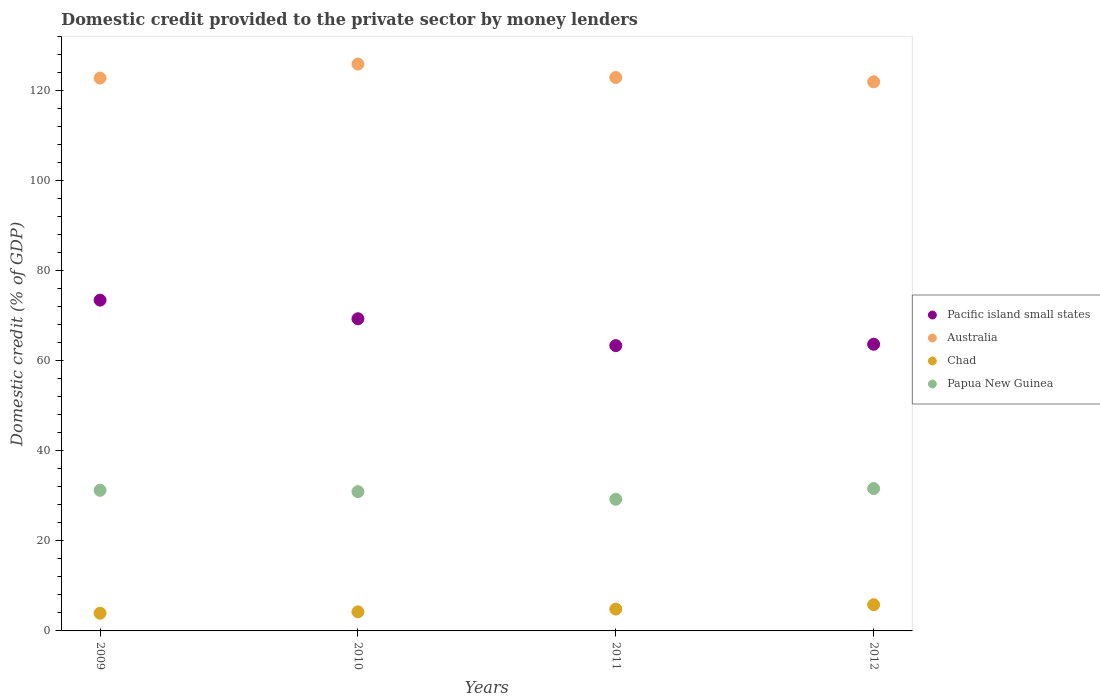How many different coloured dotlines are there?
Offer a terse response. 4. What is the domestic credit provided to the private sector by money lenders in Papua New Guinea in 2012?
Your response must be concise. 31.62. Across all years, what is the maximum domestic credit provided to the private sector by money lenders in Australia?
Keep it short and to the point. 125.92. Across all years, what is the minimum domestic credit provided to the private sector by money lenders in Chad?
Your response must be concise. 3.93. In which year was the domestic credit provided to the private sector by money lenders in Papua New Guinea maximum?
Offer a very short reply. 2012. What is the total domestic credit provided to the private sector by money lenders in Pacific island small states in the graph?
Give a very brief answer. 269.87. What is the difference between the domestic credit provided to the private sector by money lenders in Australia in 2009 and that in 2012?
Your answer should be very brief. 0.83. What is the difference between the domestic credit provided to the private sector by money lenders in Pacific island small states in 2011 and the domestic credit provided to the private sector by money lenders in Australia in 2010?
Give a very brief answer. -62.55. What is the average domestic credit provided to the private sector by money lenders in Australia per year?
Provide a succinct answer. 123.4. In the year 2010, what is the difference between the domestic credit provided to the private sector by money lenders in Chad and domestic credit provided to the private sector by money lenders in Pacific island small states?
Offer a very short reply. -65.1. In how many years, is the domestic credit provided to the private sector by money lenders in Papua New Guinea greater than 96 %?
Your answer should be very brief. 0. What is the ratio of the domestic credit provided to the private sector by money lenders in Pacific island small states in 2011 to that in 2012?
Provide a succinct answer. 1. What is the difference between the highest and the second highest domestic credit provided to the private sector by money lenders in Pacific island small states?
Make the answer very short. 4.14. What is the difference between the highest and the lowest domestic credit provided to the private sector by money lenders in Pacific island small states?
Your answer should be very brief. 10.1. Is the sum of the domestic credit provided to the private sector by money lenders in Australia in 2011 and 2012 greater than the maximum domestic credit provided to the private sector by money lenders in Chad across all years?
Your response must be concise. Yes. Is it the case that in every year, the sum of the domestic credit provided to the private sector by money lenders in Papua New Guinea and domestic credit provided to the private sector by money lenders in Australia  is greater than the sum of domestic credit provided to the private sector by money lenders in Pacific island small states and domestic credit provided to the private sector by money lenders in Chad?
Keep it short and to the point. Yes. Is it the case that in every year, the sum of the domestic credit provided to the private sector by money lenders in Pacific island small states and domestic credit provided to the private sector by money lenders in Australia  is greater than the domestic credit provided to the private sector by money lenders in Chad?
Offer a terse response. Yes. Is the domestic credit provided to the private sector by money lenders in Australia strictly greater than the domestic credit provided to the private sector by money lenders in Papua New Guinea over the years?
Offer a very short reply. Yes. Is the domestic credit provided to the private sector by money lenders in Australia strictly less than the domestic credit provided to the private sector by money lenders in Pacific island small states over the years?
Ensure brevity in your answer.  No. How many years are there in the graph?
Your answer should be very brief. 4. Does the graph contain any zero values?
Give a very brief answer. No. Does the graph contain grids?
Your response must be concise. No. Where does the legend appear in the graph?
Keep it short and to the point. Center right. How are the legend labels stacked?
Provide a succinct answer. Vertical. What is the title of the graph?
Provide a short and direct response. Domestic credit provided to the private sector by money lenders. Does "Burkina Faso" appear as one of the legend labels in the graph?
Give a very brief answer. No. What is the label or title of the X-axis?
Provide a short and direct response. Years. What is the label or title of the Y-axis?
Offer a very short reply. Domestic credit (% of GDP). What is the Domestic credit (% of GDP) of Pacific island small states in 2009?
Your answer should be very brief. 73.48. What is the Domestic credit (% of GDP) in Australia in 2009?
Offer a terse response. 122.8. What is the Domestic credit (% of GDP) of Chad in 2009?
Make the answer very short. 3.93. What is the Domestic credit (% of GDP) of Papua New Guinea in 2009?
Give a very brief answer. 31.23. What is the Domestic credit (% of GDP) of Pacific island small states in 2010?
Provide a succinct answer. 69.34. What is the Domestic credit (% of GDP) in Australia in 2010?
Provide a succinct answer. 125.92. What is the Domestic credit (% of GDP) of Chad in 2010?
Give a very brief answer. 4.24. What is the Domestic credit (% of GDP) in Papua New Guinea in 2010?
Your answer should be very brief. 30.94. What is the Domestic credit (% of GDP) of Pacific island small states in 2011?
Offer a terse response. 63.38. What is the Domestic credit (% of GDP) of Australia in 2011?
Your response must be concise. 122.93. What is the Domestic credit (% of GDP) of Chad in 2011?
Your response must be concise. 4.85. What is the Domestic credit (% of GDP) in Papua New Guinea in 2011?
Provide a succinct answer. 29.24. What is the Domestic credit (% of GDP) in Pacific island small states in 2012?
Provide a succinct answer. 63.67. What is the Domestic credit (% of GDP) in Australia in 2012?
Offer a very short reply. 121.97. What is the Domestic credit (% of GDP) of Chad in 2012?
Offer a very short reply. 5.82. What is the Domestic credit (% of GDP) in Papua New Guinea in 2012?
Your response must be concise. 31.62. Across all years, what is the maximum Domestic credit (% of GDP) in Pacific island small states?
Make the answer very short. 73.48. Across all years, what is the maximum Domestic credit (% of GDP) of Australia?
Keep it short and to the point. 125.92. Across all years, what is the maximum Domestic credit (% of GDP) in Chad?
Your answer should be very brief. 5.82. Across all years, what is the maximum Domestic credit (% of GDP) in Papua New Guinea?
Offer a terse response. 31.62. Across all years, what is the minimum Domestic credit (% of GDP) in Pacific island small states?
Offer a very short reply. 63.38. Across all years, what is the minimum Domestic credit (% of GDP) in Australia?
Your answer should be very brief. 121.97. Across all years, what is the minimum Domestic credit (% of GDP) in Chad?
Offer a very short reply. 3.93. Across all years, what is the minimum Domestic credit (% of GDP) of Papua New Guinea?
Offer a very short reply. 29.24. What is the total Domestic credit (% of GDP) of Pacific island small states in the graph?
Your answer should be very brief. 269.87. What is the total Domestic credit (% of GDP) in Australia in the graph?
Your answer should be compact. 493.62. What is the total Domestic credit (% of GDP) of Chad in the graph?
Make the answer very short. 18.83. What is the total Domestic credit (% of GDP) in Papua New Guinea in the graph?
Offer a very short reply. 123.04. What is the difference between the Domestic credit (% of GDP) of Pacific island small states in 2009 and that in 2010?
Provide a short and direct response. 4.14. What is the difference between the Domestic credit (% of GDP) of Australia in 2009 and that in 2010?
Offer a terse response. -3.13. What is the difference between the Domestic credit (% of GDP) of Chad in 2009 and that in 2010?
Your response must be concise. -0.31. What is the difference between the Domestic credit (% of GDP) in Papua New Guinea in 2009 and that in 2010?
Offer a terse response. 0.3. What is the difference between the Domestic credit (% of GDP) of Pacific island small states in 2009 and that in 2011?
Offer a terse response. 10.1. What is the difference between the Domestic credit (% of GDP) in Australia in 2009 and that in 2011?
Provide a succinct answer. -0.13. What is the difference between the Domestic credit (% of GDP) in Chad in 2009 and that in 2011?
Give a very brief answer. -0.92. What is the difference between the Domestic credit (% of GDP) of Papua New Guinea in 2009 and that in 2011?
Provide a short and direct response. 1.99. What is the difference between the Domestic credit (% of GDP) in Pacific island small states in 2009 and that in 2012?
Ensure brevity in your answer.  9.8. What is the difference between the Domestic credit (% of GDP) of Australia in 2009 and that in 2012?
Your response must be concise. 0.83. What is the difference between the Domestic credit (% of GDP) of Chad in 2009 and that in 2012?
Offer a very short reply. -1.89. What is the difference between the Domestic credit (% of GDP) of Papua New Guinea in 2009 and that in 2012?
Your answer should be very brief. -0.39. What is the difference between the Domestic credit (% of GDP) of Pacific island small states in 2010 and that in 2011?
Keep it short and to the point. 5.97. What is the difference between the Domestic credit (% of GDP) in Australia in 2010 and that in 2011?
Offer a very short reply. 3. What is the difference between the Domestic credit (% of GDP) in Chad in 2010 and that in 2011?
Provide a succinct answer. -0.61. What is the difference between the Domestic credit (% of GDP) of Papua New Guinea in 2010 and that in 2011?
Provide a short and direct response. 1.69. What is the difference between the Domestic credit (% of GDP) in Pacific island small states in 2010 and that in 2012?
Offer a terse response. 5.67. What is the difference between the Domestic credit (% of GDP) of Australia in 2010 and that in 2012?
Keep it short and to the point. 3.95. What is the difference between the Domestic credit (% of GDP) in Chad in 2010 and that in 2012?
Provide a short and direct response. -1.58. What is the difference between the Domestic credit (% of GDP) of Papua New Guinea in 2010 and that in 2012?
Your answer should be very brief. -0.69. What is the difference between the Domestic credit (% of GDP) in Pacific island small states in 2011 and that in 2012?
Keep it short and to the point. -0.3. What is the difference between the Domestic credit (% of GDP) in Australia in 2011 and that in 2012?
Keep it short and to the point. 0.96. What is the difference between the Domestic credit (% of GDP) of Chad in 2011 and that in 2012?
Provide a short and direct response. -0.97. What is the difference between the Domestic credit (% of GDP) of Papua New Guinea in 2011 and that in 2012?
Keep it short and to the point. -2.38. What is the difference between the Domestic credit (% of GDP) of Pacific island small states in 2009 and the Domestic credit (% of GDP) of Australia in 2010?
Make the answer very short. -52.45. What is the difference between the Domestic credit (% of GDP) of Pacific island small states in 2009 and the Domestic credit (% of GDP) of Chad in 2010?
Ensure brevity in your answer.  69.24. What is the difference between the Domestic credit (% of GDP) of Pacific island small states in 2009 and the Domestic credit (% of GDP) of Papua New Guinea in 2010?
Your answer should be very brief. 42.54. What is the difference between the Domestic credit (% of GDP) of Australia in 2009 and the Domestic credit (% of GDP) of Chad in 2010?
Make the answer very short. 118.56. What is the difference between the Domestic credit (% of GDP) in Australia in 2009 and the Domestic credit (% of GDP) in Papua New Guinea in 2010?
Provide a short and direct response. 91.86. What is the difference between the Domestic credit (% of GDP) of Chad in 2009 and the Domestic credit (% of GDP) of Papua New Guinea in 2010?
Offer a very short reply. -27. What is the difference between the Domestic credit (% of GDP) in Pacific island small states in 2009 and the Domestic credit (% of GDP) in Australia in 2011?
Keep it short and to the point. -49.45. What is the difference between the Domestic credit (% of GDP) in Pacific island small states in 2009 and the Domestic credit (% of GDP) in Chad in 2011?
Provide a short and direct response. 68.63. What is the difference between the Domestic credit (% of GDP) of Pacific island small states in 2009 and the Domestic credit (% of GDP) of Papua New Guinea in 2011?
Make the answer very short. 44.23. What is the difference between the Domestic credit (% of GDP) of Australia in 2009 and the Domestic credit (% of GDP) of Chad in 2011?
Your answer should be compact. 117.95. What is the difference between the Domestic credit (% of GDP) of Australia in 2009 and the Domestic credit (% of GDP) of Papua New Guinea in 2011?
Ensure brevity in your answer.  93.55. What is the difference between the Domestic credit (% of GDP) of Chad in 2009 and the Domestic credit (% of GDP) of Papua New Guinea in 2011?
Offer a terse response. -25.31. What is the difference between the Domestic credit (% of GDP) in Pacific island small states in 2009 and the Domestic credit (% of GDP) in Australia in 2012?
Your response must be concise. -48.49. What is the difference between the Domestic credit (% of GDP) of Pacific island small states in 2009 and the Domestic credit (% of GDP) of Chad in 2012?
Give a very brief answer. 67.66. What is the difference between the Domestic credit (% of GDP) in Pacific island small states in 2009 and the Domestic credit (% of GDP) in Papua New Guinea in 2012?
Provide a succinct answer. 41.85. What is the difference between the Domestic credit (% of GDP) of Australia in 2009 and the Domestic credit (% of GDP) of Chad in 2012?
Your response must be concise. 116.98. What is the difference between the Domestic credit (% of GDP) in Australia in 2009 and the Domestic credit (% of GDP) in Papua New Guinea in 2012?
Make the answer very short. 91.17. What is the difference between the Domestic credit (% of GDP) of Chad in 2009 and the Domestic credit (% of GDP) of Papua New Guinea in 2012?
Provide a succinct answer. -27.69. What is the difference between the Domestic credit (% of GDP) in Pacific island small states in 2010 and the Domestic credit (% of GDP) in Australia in 2011?
Provide a succinct answer. -53.59. What is the difference between the Domestic credit (% of GDP) in Pacific island small states in 2010 and the Domestic credit (% of GDP) in Chad in 2011?
Ensure brevity in your answer.  64.49. What is the difference between the Domestic credit (% of GDP) of Pacific island small states in 2010 and the Domestic credit (% of GDP) of Papua New Guinea in 2011?
Give a very brief answer. 40.1. What is the difference between the Domestic credit (% of GDP) of Australia in 2010 and the Domestic credit (% of GDP) of Chad in 2011?
Make the answer very short. 121.07. What is the difference between the Domestic credit (% of GDP) in Australia in 2010 and the Domestic credit (% of GDP) in Papua New Guinea in 2011?
Make the answer very short. 96.68. What is the difference between the Domestic credit (% of GDP) of Chad in 2010 and the Domestic credit (% of GDP) of Papua New Guinea in 2011?
Your answer should be compact. -25.01. What is the difference between the Domestic credit (% of GDP) of Pacific island small states in 2010 and the Domestic credit (% of GDP) of Australia in 2012?
Ensure brevity in your answer.  -52.63. What is the difference between the Domestic credit (% of GDP) of Pacific island small states in 2010 and the Domestic credit (% of GDP) of Chad in 2012?
Provide a succinct answer. 63.52. What is the difference between the Domestic credit (% of GDP) in Pacific island small states in 2010 and the Domestic credit (% of GDP) in Papua New Guinea in 2012?
Your response must be concise. 37.72. What is the difference between the Domestic credit (% of GDP) in Australia in 2010 and the Domestic credit (% of GDP) in Chad in 2012?
Your answer should be very brief. 120.11. What is the difference between the Domestic credit (% of GDP) of Australia in 2010 and the Domestic credit (% of GDP) of Papua New Guinea in 2012?
Ensure brevity in your answer.  94.3. What is the difference between the Domestic credit (% of GDP) in Chad in 2010 and the Domestic credit (% of GDP) in Papua New Guinea in 2012?
Your answer should be very brief. -27.39. What is the difference between the Domestic credit (% of GDP) of Pacific island small states in 2011 and the Domestic credit (% of GDP) of Australia in 2012?
Your response must be concise. -58.59. What is the difference between the Domestic credit (% of GDP) in Pacific island small states in 2011 and the Domestic credit (% of GDP) in Chad in 2012?
Offer a very short reply. 57.56. What is the difference between the Domestic credit (% of GDP) in Pacific island small states in 2011 and the Domestic credit (% of GDP) in Papua New Guinea in 2012?
Provide a succinct answer. 31.75. What is the difference between the Domestic credit (% of GDP) in Australia in 2011 and the Domestic credit (% of GDP) in Chad in 2012?
Make the answer very short. 117.11. What is the difference between the Domestic credit (% of GDP) in Australia in 2011 and the Domestic credit (% of GDP) in Papua New Guinea in 2012?
Ensure brevity in your answer.  91.3. What is the difference between the Domestic credit (% of GDP) of Chad in 2011 and the Domestic credit (% of GDP) of Papua New Guinea in 2012?
Ensure brevity in your answer.  -26.78. What is the average Domestic credit (% of GDP) of Pacific island small states per year?
Offer a very short reply. 67.47. What is the average Domestic credit (% of GDP) in Australia per year?
Your answer should be very brief. 123.4. What is the average Domestic credit (% of GDP) of Chad per year?
Your response must be concise. 4.71. What is the average Domestic credit (% of GDP) in Papua New Guinea per year?
Your answer should be compact. 30.76. In the year 2009, what is the difference between the Domestic credit (% of GDP) of Pacific island small states and Domestic credit (% of GDP) of Australia?
Your answer should be compact. -49.32. In the year 2009, what is the difference between the Domestic credit (% of GDP) of Pacific island small states and Domestic credit (% of GDP) of Chad?
Your response must be concise. 69.55. In the year 2009, what is the difference between the Domestic credit (% of GDP) in Pacific island small states and Domestic credit (% of GDP) in Papua New Guinea?
Your answer should be very brief. 42.24. In the year 2009, what is the difference between the Domestic credit (% of GDP) of Australia and Domestic credit (% of GDP) of Chad?
Your answer should be compact. 118.87. In the year 2009, what is the difference between the Domestic credit (% of GDP) in Australia and Domestic credit (% of GDP) in Papua New Guinea?
Ensure brevity in your answer.  91.56. In the year 2009, what is the difference between the Domestic credit (% of GDP) in Chad and Domestic credit (% of GDP) in Papua New Guinea?
Keep it short and to the point. -27.3. In the year 2010, what is the difference between the Domestic credit (% of GDP) of Pacific island small states and Domestic credit (% of GDP) of Australia?
Your answer should be very brief. -56.58. In the year 2010, what is the difference between the Domestic credit (% of GDP) in Pacific island small states and Domestic credit (% of GDP) in Chad?
Offer a very short reply. 65.1. In the year 2010, what is the difference between the Domestic credit (% of GDP) in Pacific island small states and Domestic credit (% of GDP) in Papua New Guinea?
Provide a succinct answer. 38.41. In the year 2010, what is the difference between the Domestic credit (% of GDP) of Australia and Domestic credit (% of GDP) of Chad?
Keep it short and to the point. 121.69. In the year 2010, what is the difference between the Domestic credit (% of GDP) of Australia and Domestic credit (% of GDP) of Papua New Guinea?
Your response must be concise. 94.99. In the year 2010, what is the difference between the Domestic credit (% of GDP) in Chad and Domestic credit (% of GDP) in Papua New Guinea?
Provide a short and direct response. -26.7. In the year 2011, what is the difference between the Domestic credit (% of GDP) in Pacific island small states and Domestic credit (% of GDP) in Australia?
Keep it short and to the point. -59.55. In the year 2011, what is the difference between the Domestic credit (% of GDP) of Pacific island small states and Domestic credit (% of GDP) of Chad?
Provide a succinct answer. 58.53. In the year 2011, what is the difference between the Domestic credit (% of GDP) of Pacific island small states and Domestic credit (% of GDP) of Papua New Guinea?
Provide a short and direct response. 34.13. In the year 2011, what is the difference between the Domestic credit (% of GDP) of Australia and Domestic credit (% of GDP) of Chad?
Ensure brevity in your answer.  118.08. In the year 2011, what is the difference between the Domestic credit (% of GDP) in Australia and Domestic credit (% of GDP) in Papua New Guinea?
Make the answer very short. 93.68. In the year 2011, what is the difference between the Domestic credit (% of GDP) of Chad and Domestic credit (% of GDP) of Papua New Guinea?
Provide a succinct answer. -24.4. In the year 2012, what is the difference between the Domestic credit (% of GDP) of Pacific island small states and Domestic credit (% of GDP) of Australia?
Offer a very short reply. -58.29. In the year 2012, what is the difference between the Domestic credit (% of GDP) of Pacific island small states and Domestic credit (% of GDP) of Chad?
Offer a very short reply. 57.86. In the year 2012, what is the difference between the Domestic credit (% of GDP) of Pacific island small states and Domestic credit (% of GDP) of Papua New Guinea?
Provide a short and direct response. 32.05. In the year 2012, what is the difference between the Domestic credit (% of GDP) in Australia and Domestic credit (% of GDP) in Chad?
Make the answer very short. 116.15. In the year 2012, what is the difference between the Domestic credit (% of GDP) in Australia and Domestic credit (% of GDP) in Papua New Guinea?
Your response must be concise. 90.34. In the year 2012, what is the difference between the Domestic credit (% of GDP) in Chad and Domestic credit (% of GDP) in Papua New Guinea?
Provide a short and direct response. -25.81. What is the ratio of the Domestic credit (% of GDP) in Pacific island small states in 2009 to that in 2010?
Provide a short and direct response. 1.06. What is the ratio of the Domestic credit (% of GDP) of Australia in 2009 to that in 2010?
Offer a very short reply. 0.98. What is the ratio of the Domestic credit (% of GDP) of Chad in 2009 to that in 2010?
Provide a short and direct response. 0.93. What is the ratio of the Domestic credit (% of GDP) of Papua New Guinea in 2009 to that in 2010?
Keep it short and to the point. 1.01. What is the ratio of the Domestic credit (% of GDP) in Pacific island small states in 2009 to that in 2011?
Your answer should be very brief. 1.16. What is the ratio of the Domestic credit (% of GDP) in Chad in 2009 to that in 2011?
Provide a succinct answer. 0.81. What is the ratio of the Domestic credit (% of GDP) of Papua New Guinea in 2009 to that in 2011?
Your response must be concise. 1.07. What is the ratio of the Domestic credit (% of GDP) of Pacific island small states in 2009 to that in 2012?
Offer a terse response. 1.15. What is the ratio of the Domestic credit (% of GDP) of Australia in 2009 to that in 2012?
Provide a short and direct response. 1.01. What is the ratio of the Domestic credit (% of GDP) in Chad in 2009 to that in 2012?
Provide a succinct answer. 0.68. What is the ratio of the Domestic credit (% of GDP) of Papua New Guinea in 2009 to that in 2012?
Your answer should be compact. 0.99. What is the ratio of the Domestic credit (% of GDP) of Pacific island small states in 2010 to that in 2011?
Offer a terse response. 1.09. What is the ratio of the Domestic credit (% of GDP) of Australia in 2010 to that in 2011?
Your answer should be compact. 1.02. What is the ratio of the Domestic credit (% of GDP) of Chad in 2010 to that in 2011?
Your answer should be compact. 0.87. What is the ratio of the Domestic credit (% of GDP) of Papua New Guinea in 2010 to that in 2011?
Ensure brevity in your answer.  1.06. What is the ratio of the Domestic credit (% of GDP) in Pacific island small states in 2010 to that in 2012?
Your answer should be compact. 1.09. What is the ratio of the Domestic credit (% of GDP) in Australia in 2010 to that in 2012?
Provide a short and direct response. 1.03. What is the ratio of the Domestic credit (% of GDP) in Chad in 2010 to that in 2012?
Your answer should be compact. 0.73. What is the ratio of the Domestic credit (% of GDP) of Papua New Guinea in 2010 to that in 2012?
Offer a terse response. 0.98. What is the ratio of the Domestic credit (% of GDP) of Australia in 2011 to that in 2012?
Make the answer very short. 1.01. What is the ratio of the Domestic credit (% of GDP) of Chad in 2011 to that in 2012?
Your response must be concise. 0.83. What is the ratio of the Domestic credit (% of GDP) of Papua New Guinea in 2011 to that in 2012?
Keep it short and to the point. 0.92. What is the difference between the highest and the second highest Domestic credit (% of GDP) in Pacific island small states?
Your answer should be very brief. 4.14. What is the difference between the highest and the second highest Domestic credit (% of GDP) in Australia?
Keep it short and to the point. 3. What is the difference between the highest and the second highest Domestic credit (% of GDP) in Chad?
Make the answer very short. 0.97. What is the difference between the highest and the second highest Domestic credit (% of GDP) of Papua New Guinea?
Your answer should be very brief. 0.39. What is the difference between the highest and the lowest Domestic credit (% of GDP) of Pacific island small states?
Provide a short and direct response. 10.1. What is the difference between the highest and the lowest Domestic credit (% of GDP) of Australia?
Give a very brief answer. 3.95. What is the difference between the highest and the lowest Domestic credit (% of GDP) in Chad?
Your response must be concise. 1.89. What is the difference between the highest and the lowest Domestic credit (% of GDP) of Papua New Guinea?
Give a very brief answer. 2.38. 